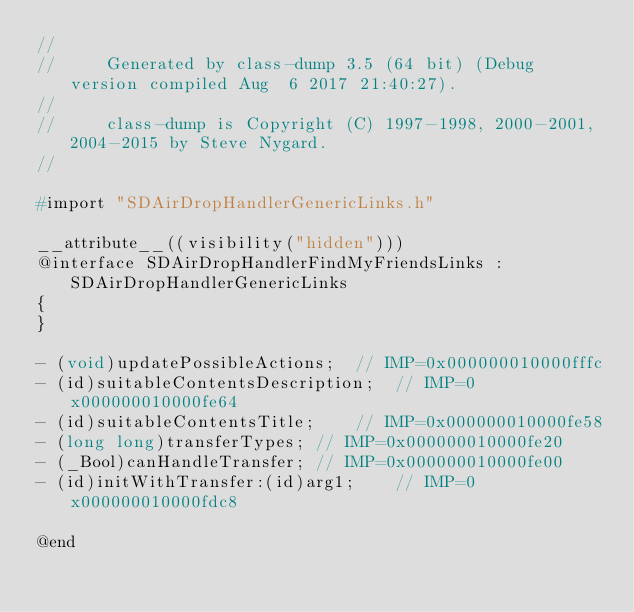<code> <loc_0><loc_0><loc_500><loc_500><_C_>//
//     Generated by class-dump 3.5 (64 bit) (Debug version compiled Aug  6 2017 21:40:27).
//
//     class-dump is Copyright (C) 1997-1998, 2000-2001, 2004-2015 by Steve Nygard.
//

#import "SDAirDropHandlerGenericLinks.h"

__attribute__((visibility("hidden")))
@interface SDAirDropHandlerFindMyFriendsLinks : SDAirDropHandlerGenericLinks
{
}

- (void)updatePossibleActions;	// IMP=0x000000010000fffc
- (id)suitableContentsDescription;	// IMP=0x000000010000fe64
- (id)suitableContentsTitle;	// IMP=0x000000010000fe58
- (long long)transferTypes;	// IMP=0x000000010000fe20
- (_Bool)canHandleTransfer;	// IMP=0x000000010000fe00
- (id)initWithTransfer:(id)arg1;	// IMP=0x000000010000fdc8

@end

</code> 